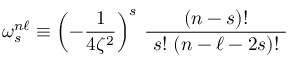<formula> <loc_0><loc_0><loc_500><loc_500>\omega _ { s } ^ { n \ell } \equiv \left ( - { \frac { 1 } { 4 \zeta ^ { 2 } } } \right ) ^ { s } \, { \frac { ( n - s ) ! } { s ! ( n - \ell - 2 s ) ! } }</formula> 